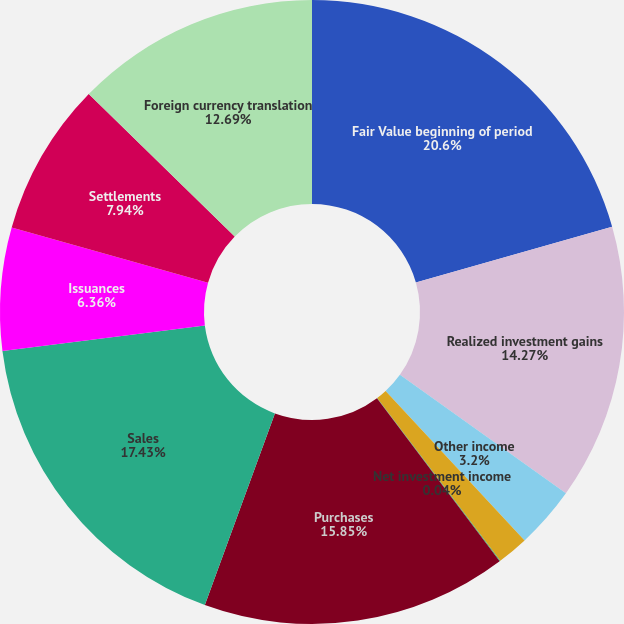<chart> <loc_0><loc_0><loc_500><loc_500><pie_chart><fcel>Fair Value beginning of period<fcel>Realized investment gains<fcel>Other income<fcel>Included in other<fcel>Net investment income<fcel>Purchases<fcel>Sales<fcel>Issuances<fcel>Settlements<fcel>Foreign currency translation<nl><fcel>20.6%<fcel>14.27%<fcel>3.2%<fcel>1.62%<fcel>0.04%<fcel>15.85%<fcel>17.43%<fcel>6.36%<fcel>7.94%<fcel>12.69%<nl></chart> 